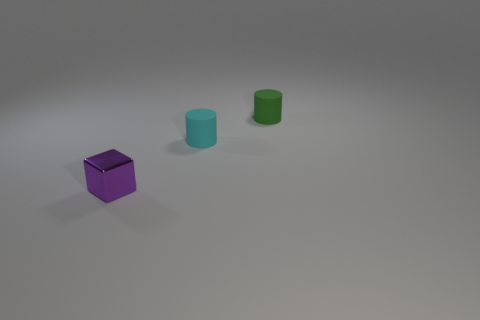Add 3 big red things. How many objects exist? 6 Subtract all cubes. How many objects are left? 2 Subtract all small shiny cubes. Subtract all tiny purple metal blocks. How many objects are left? 1 Add 2 green matte things. How many green matte things are left? 3 Add 3 small purple metal objects. How many small purple metal objects exist? 4 Subtract 0 purple cylinders. How many objects are left? 3 